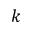Convert formula to latex. <formula><loc_0><loc_0><loc_500><loc_500>k</formula> 